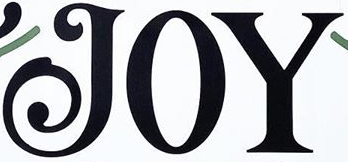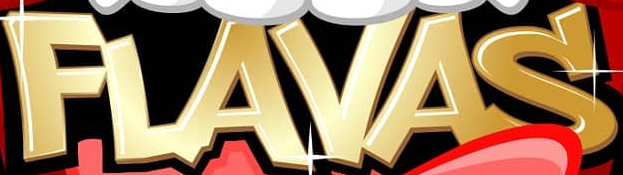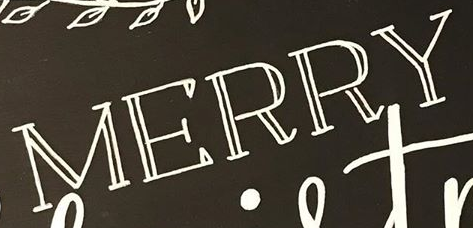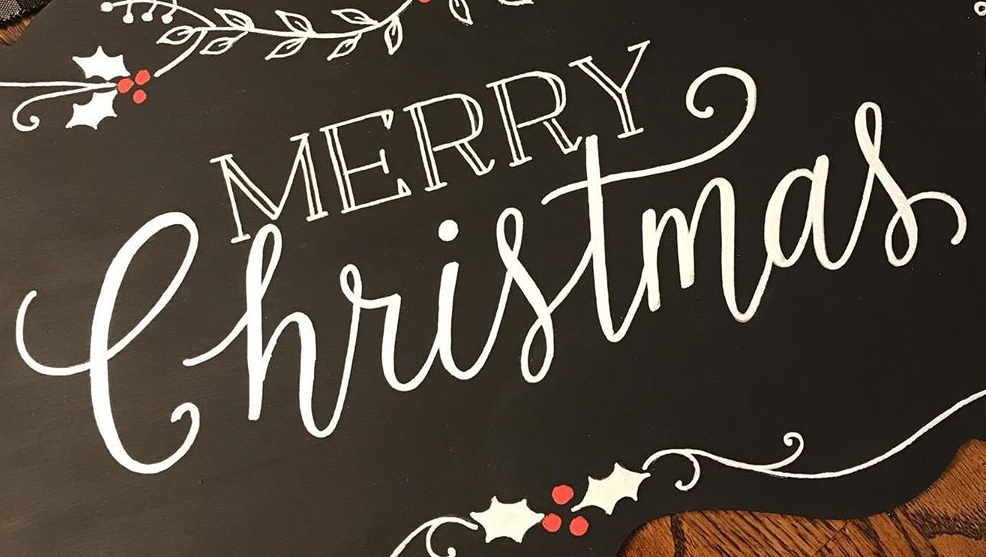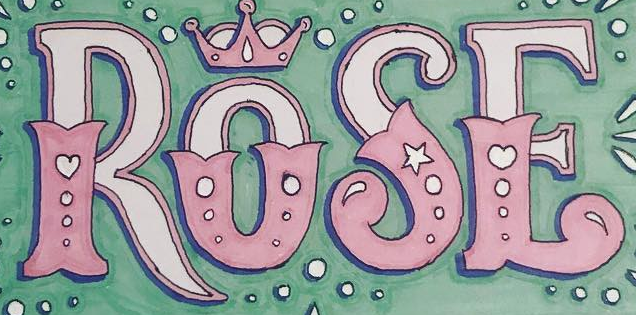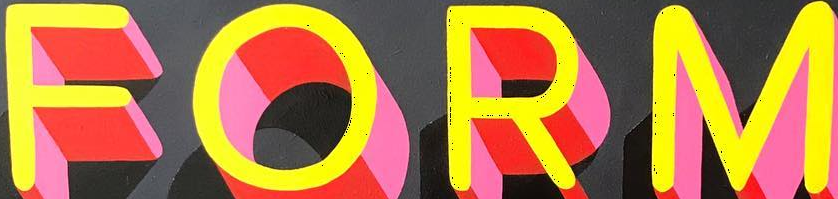Identify the words shown in these images in order, separated by a semicolon. JOY; FLAVAS; MERRY; Christmas; ROSE; FORM 